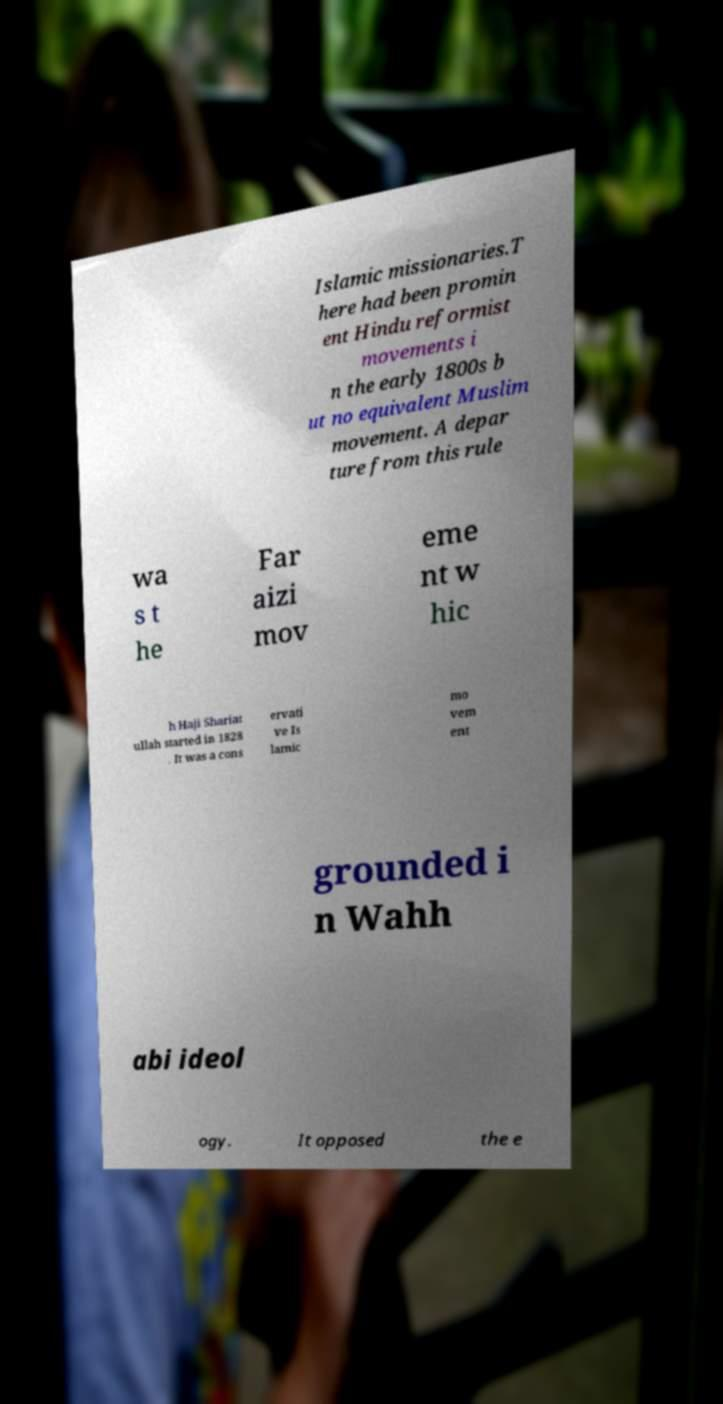Could you extract and type out the text from this image? Islamic missionaries.T here had been promin ent Hindu reformist movements i n the early 1800s b ut no equivalent Muslim movement. A depar ture from this rule wa s t he Far aizi mov eme nt w hic h Haji Shariat ullah started in 1828 . It was a cons ervati ve Is lamic mo vem ent grounded i n Wahh abi ideol ogy. It opposed the e 